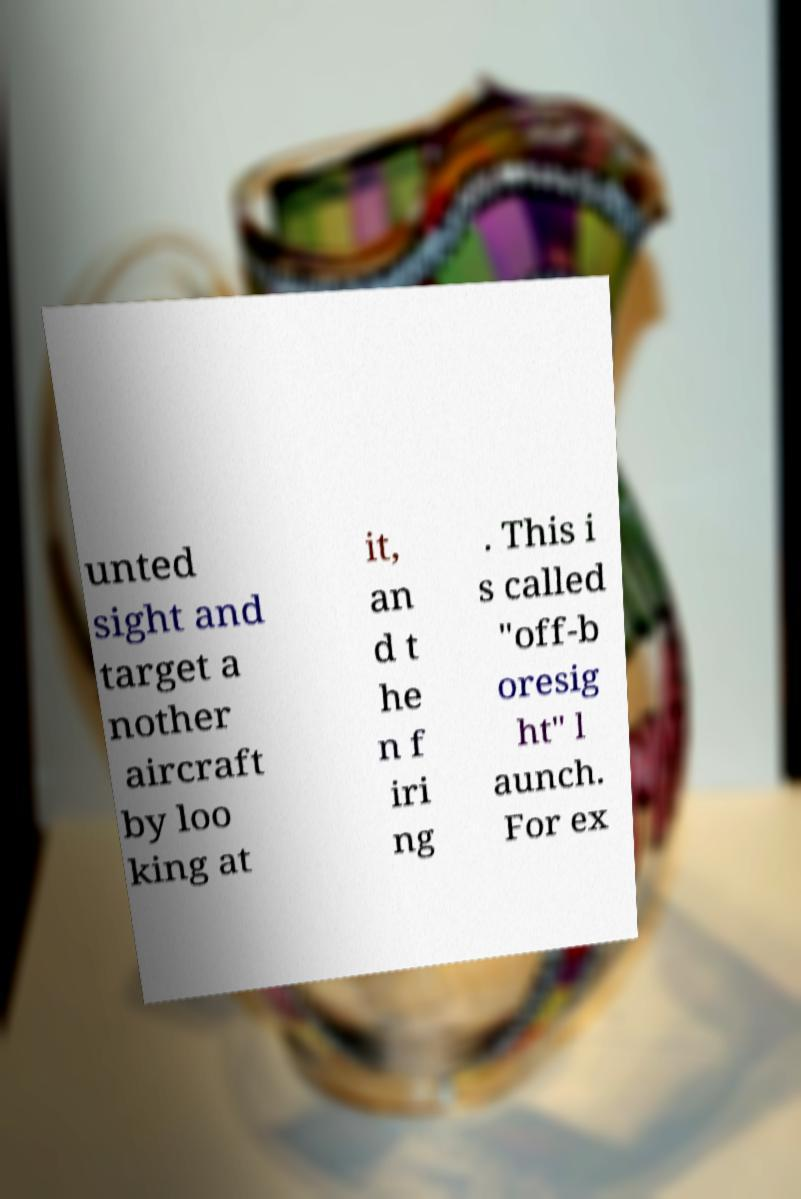For documentation purposes, I need the text within this image transcribed. Could you provide that? unted sight and target a nother aircraft by loo king at it, an d t he n f iri ng . This i s called "off-b oresig ht" l aunch. For ex 